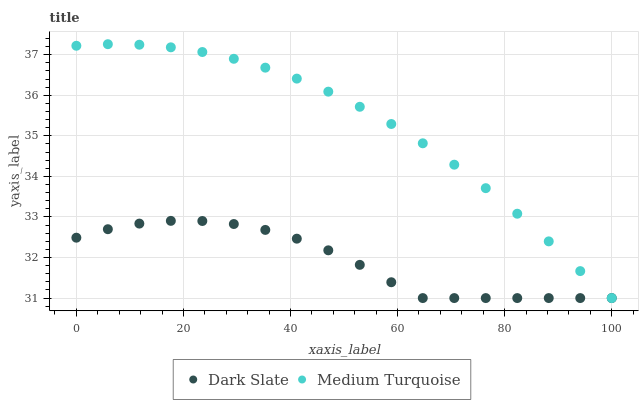Does Dark Slate have the minimum area under the curve?
Answer yes or no. Yes. Does Medium Turquoise have the maximum area under the curve?
Answer yes or no. Yes. Does Medium Turquoise have the minimum area under the curve?
Answer yes or no. No. Is Medium Turquoise the smoothest?
Answer yes or no. Yes. Is Dark Slate the roughest?
Answer yes or no. Yes. Is Medium Turquoise the roughest?
Answer yes or no. No. Does Dark Slate have the lowest value?
Answer yes or no. Yes. Does Medium Turquoise have the highest value?
Answer yes or no. Yes. Does Dark Slate intersect Medium Turquoise?
Answer yes or no. Yes. Is Dark Slate less than Medium Turquoise?
Answer yes or no. No. Is Dark Slate greater than Medium Turquoise?
Answer yes or no. No. 